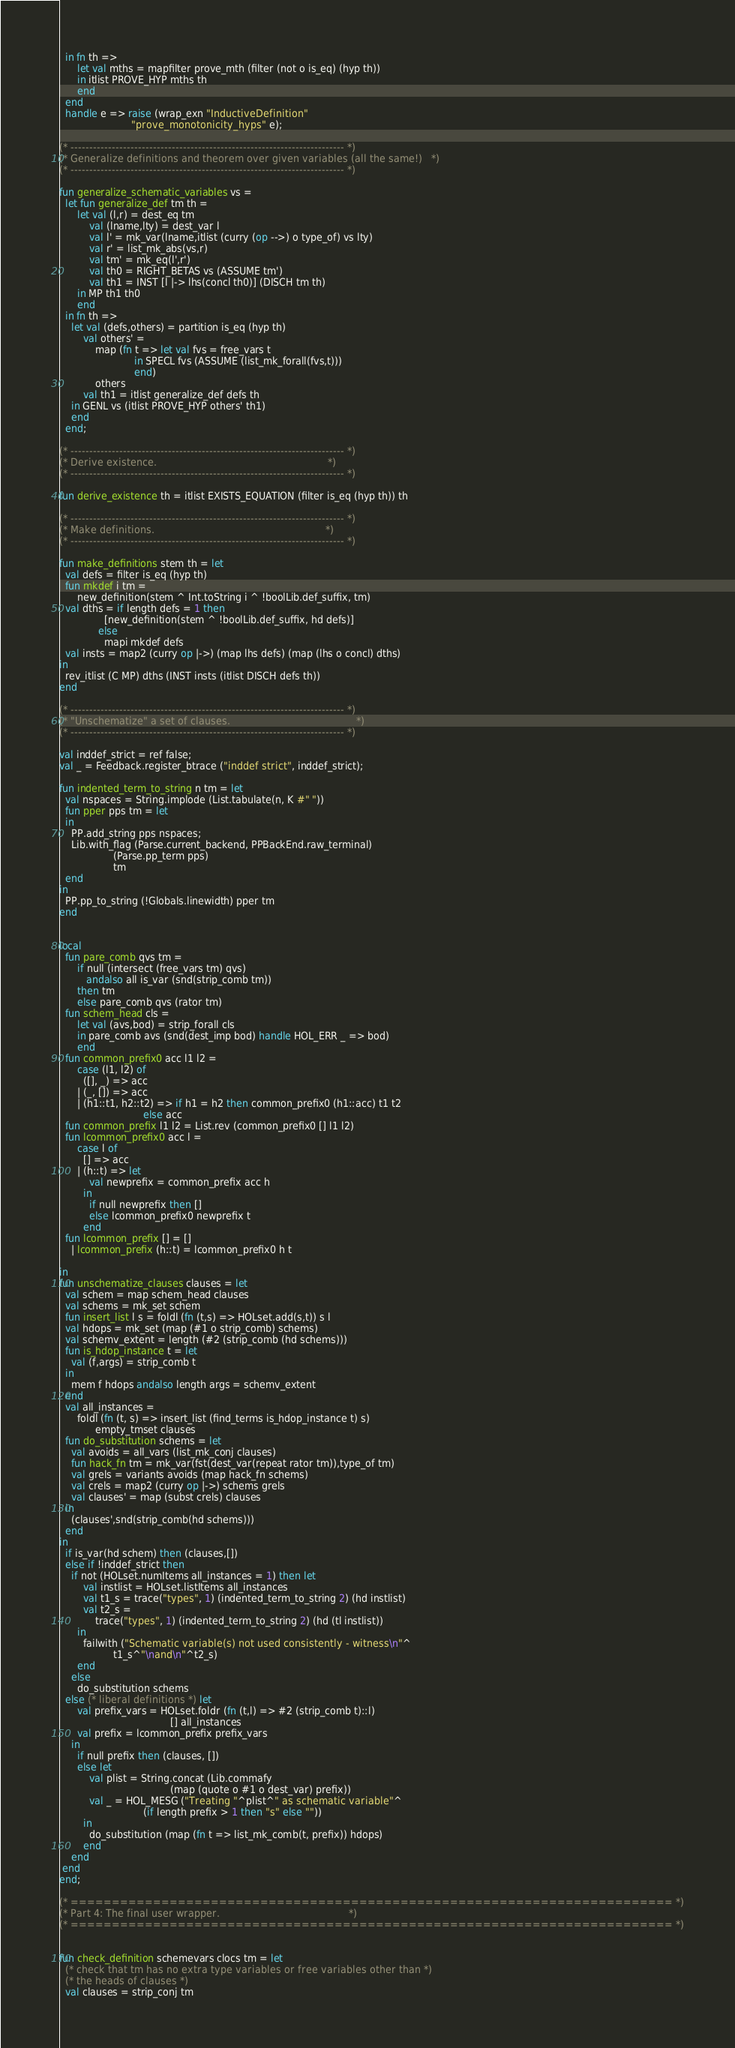Convert code to text. <code><loc_0><loc_0><loc_500><loc_500><_SML_>  in fn th =>
      let val mths = mapfilter prove_mth (filter (not o is_eq) (hyp th))
      in itlist PROVE_HYP mths th
      end
  end
  handle e => raise (wrap_exn "InductiveDefinition"
                        "prove_monotonicity_hyps" e);

(* ------------------------------------------------------------------------- *)
(* Generalize definitions and theorem over given variables (all the same!)   *)
(* ------------------------------------------------------------------------- *)

fun generalize_schematic_variables vs =
  let fun generalize_def tm th =
      let val (l,r) = dest_eq tm
          val (lname,lty) = dest_var l
          val l' = mk_var(lname,itlist (curry (op -->) o type_of) vs lty)
          val r' = list_mk_abs(vs,r)
          val tm' = mk_eq(l',r')
          val th0 = RIGHT_BETAS vs (ASSUME tm')
          val th1 = INST [l |-> lhs(concl th0)] (DISCH tm th)
      in MP th1 th0
      end
  in fn th =>
    let val (defs,others) = partition is_eq (hyp th)
        val others' =
            map (fn t => let val fvs = free_vars t
                         in SPECL fvs (ASSUME (list_mk_forall(fvs,t)))
                         end)
            others
        val th1 = itlist generalize_def defs th
    in GENL vs (itlist PROVE_HYP others' th1)
    end
  end;

(* ------------------------------------------------------------------------- *)
(* Derive existence.                                                         *)
(* ------------------------------------------------------------------------- *)

fun derive_existence th = itlist EXISTS_EQUATION (filter is_eq (hyp th)) th

(* ------------------------------------------------------------------------- *)
(* Make definitions.                                                         *)
(* ------------------------------------------------------------------------- *)

fun make_definitions stem th = let
  val defs = filter is_eq (hyp th)
  fun mkdef i tm =
      new_definition(stem ^ Int.toString i ^ !boolLib.def_suffix, tm)
  val dths = if length defs = 1 then
               [new_definition(stem ^ !boolLib.def_suffix, hd defs)]
             else
               mapi mkdef defs
  val insts = map2 (curry op |->) (map lhs defs) (map (lhs o concl) dths)
in
  rev_itlist (C MP) dths (INST insts (itlist DISCH defs th))
end

(* ------------------------------------------------------------------------- *)
(* "Unschematize" a set of clauses.                                          *)
(* ------------------------------------------------------------------------- *)

val inddef_strict = ref false;
val _ = Feedback.register_btrace ("inddef strict", inddef_strict);

fun indented_term_to_string n tm = let
  val nspaces = String.implode (List.tabulate(n, K #" "))
  fun pper pps tm = let
  in
    PP.add_string pps nspaces;
    Lib.with_flag (Parse.current_backend, PPBackEnd.raw_terminal)
                  (Parse.pp_term pps)
                  tm
  end
in
  PP.pp_to_string (!Globals.linewidth) pper tm
end


local
  fun pare_comb qvs tm =
      if null (intersect (free_vars tm) qvs)
         andalso all is_var (snd(strip_comb tm))
      then tm
      else pare_comb qvs (rator tm)
  fun schem_head cls =
      let val (avs,bod) = strip_forall cls
      in pare_comb avs (snd(dest_imp bod) handle HOL_ERR _ => bod)
      end
  fun common_prefix0 acc l1 l2 =
      case (l1, l2) of
        ([], _) => acc
      | (_, []) => acc
      | (h1::t1, h2::t2) => if h1 = h2 then common_prefix0 (h1::acc) t1 t2
                            else acc
  fun common_prefix l1 l2 = List.rev (common_prefix0 [] l1 l2)
  fun lcommon_prefix0 acc l =
      case l of
        [] => acc
      | (h::t) => let
          val newprefix = common_prefix acc h
        in
          if null newprefix then []
          else lcommon_prefix0 newprefix t
        end
  fun lcommon_prefix [] = []
    | lcommon_prefix (h::t) = lcommon_prefix0 h t

in
fun unschematize_clauses clauses = let
  val schem = map schem_head clauses
  val schems = mk_set schem
  fun insert_list l s = foldl (fn (t,s) => HOLset.add(s,t)) s l
  val hdops = mk_set (map (#1 o strip_comb) schems)
  val schemv_extent = length (#2 (strip_comb (hd schems)))
  fun is_hdop_instance t = let
    val (f,args) = strip_comb t
  in
    mem f hdops andalso length args = schemv_extent
  end
  val all_instances =
      foldl (fn (t, s) => insert_list (find_terms is_hdop_instance t) s)
            empty_tmset clauses
  fun do_substitution schems = let
    val avoids = all_vars (list_mk_conj clauses)
    fun hack_fn tm = mk_var(fst(dest_var(repeat rator tm)),type_of tm)
    val grels = variants avoids (map hack_fn schems)
    val crels = map2 (curry op |->) schems grels
    val clauses' = map (subst crels) clauses
  in
    (clauses',snd(strip_comb(hd schems)))
  end
in
  if is_var(hd schem) then (clauses,[])
  else if !inddef_strict then
    if not (HOLset.numItems all_instances = 1) then let
        val instlist = HOLset.listItems all_instances
        val t1_s = trace("types", 1) (indented_term_to_string 2) (hd instlist)
        val t2_s =
            trace("types", 1) (indented_term_to_string 2) (hd (tl instlist))
      in
        failwith ("Schematic variable(s) not used consistently - witness\n"^
                  t1_s^"\nand\n"^t2_s)
      end
    else
      do_substitution schems
  else (* liberal definitions *) let
      val prefix_vars = HOLset.foldr (fn (t,l) => #2 (strip_comb t)::l)
                                     [] all_instances
      val prefix = lcommon_prefix prefix_vars
    in
      if null prefix then (clauses, [])
      else let
          val plist = String.concat (Lib.commafy
                                     (map (quote o #1 o dest_var) prefix))
          val _ = HOL_MESG ("Treating "^plist^" as schematic variable"^
                            (if length prefix > 1 then "s" else ""))
        in
          do_substitution (map (fn t => list_mk_comb(t, prefix)) hdops)
        end
    end
 end
end;

(* ========================================================================= *)
(* Part 4: The final user wrapper.                                           *)
(* ========================================================================= *)


fun check_definition schemevars clocs tm = let
  (* check that tm has no extra type variables or free variables other than *)
  (* the heads of clauses *)
  val clauses = strip_conj tm</code> 